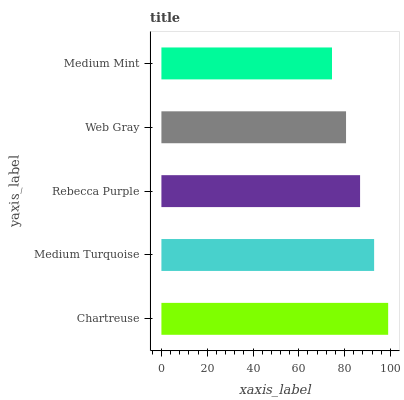Is Medium Mint the minimum?
Answer yes or no. Yes. Is Chartreuse the maximum?
Answer yes or no. Yes. Is Medium Turquoise the minimum?
Answer yes or no. No. Is Medium Turquoise the maximum?
Answer yes or no. No. Is Chartreuse greater than Medium Turquoise?
Answer yes or no. Yes. Is Medium Turquoise less than Chartreuse?
Answer yes or no. Yes. Is Medium Turquoise greater than Chartreuse?
Answer yes or no. No. Is Chartreuse less than Medium Turquoise?
Answer yes or no. No. Is Rebecca Purple the high median?
Answer yes or no. Yes. Is Rebecca Purple the low median?
Answer yes or no. Yes. Is Medium Mint the high median?
Answer yes or no. No. Is Chartreuse the low median?
Answer yes or no. No. 